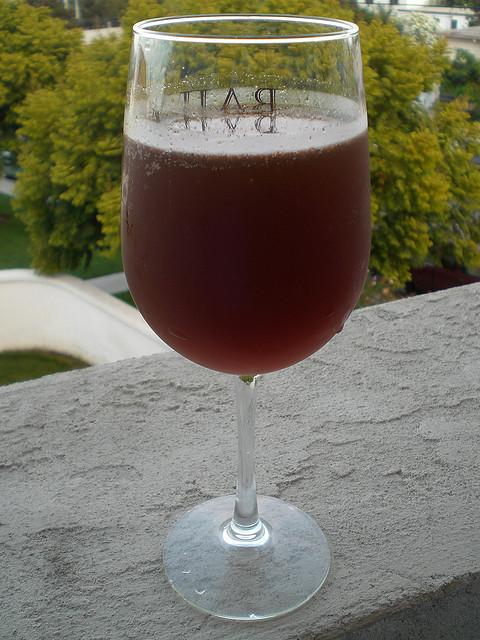Is this beer in a wine glass?
Give a very brief answer. Yes. Would drinking this make someone drunk?
Write a very short answer. Yes. Is the glass empty?
Concise answer only. No. What is the glass sitting on?
Give a very brief answer. Cement. Is this glass clean?
Short answer required. Yes. 